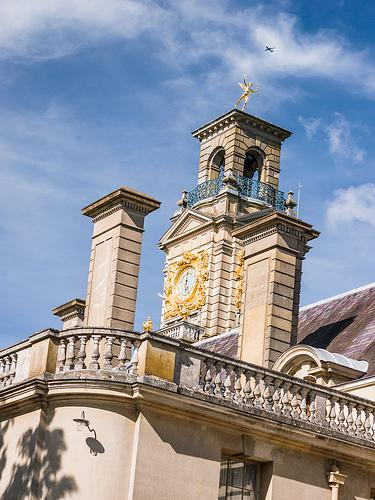Question: what color is the statue on top of the tower?
Choices:
A. White.
B. Bronze.
C. Gold.
D. Silver.
Answer with the letter. Answer: C Question: where are the clouds?
Choices:
A. Hanging over the mountains.
B. Rolling across the lake.
C. Blanketing the valley below.
D. In the sky.
Answer with the letter. Answer: D Question: what are the black images seen on the building?
Choices:
A. Shadows.
B. Darkness.
C. Murkiness.
D. Shade.
Answer with the letter. Answer: A 